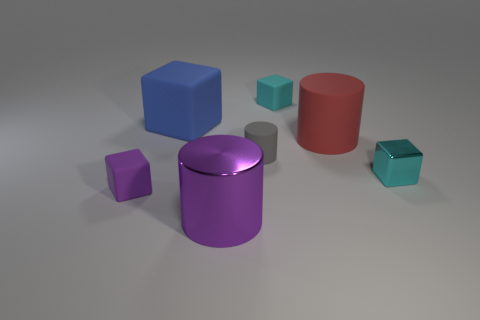Add 2 cyan objects. How many objects exist? 9 Subtract all big cylinders. How many cylinders are left? 1 Subtract 3 cubes. How many cubes are left? 1 Subtract all purple cubes. How many cubes are left? 3 Add 4 small cyan matte cubes. How many small cyan matte cubes are left? 5 Add 5 big cyan metal cubes. How many big cyan metal cubes exist? 5 Subtract 0 red balls. How many objects are left? 7 Subtract all cylinders. How many objects are left? 4 Subtract all blue cylinders. Subtract all brown balls. How many cylinders are left? 3 Subtract all purple balls. How many red cylinders are left? 1 